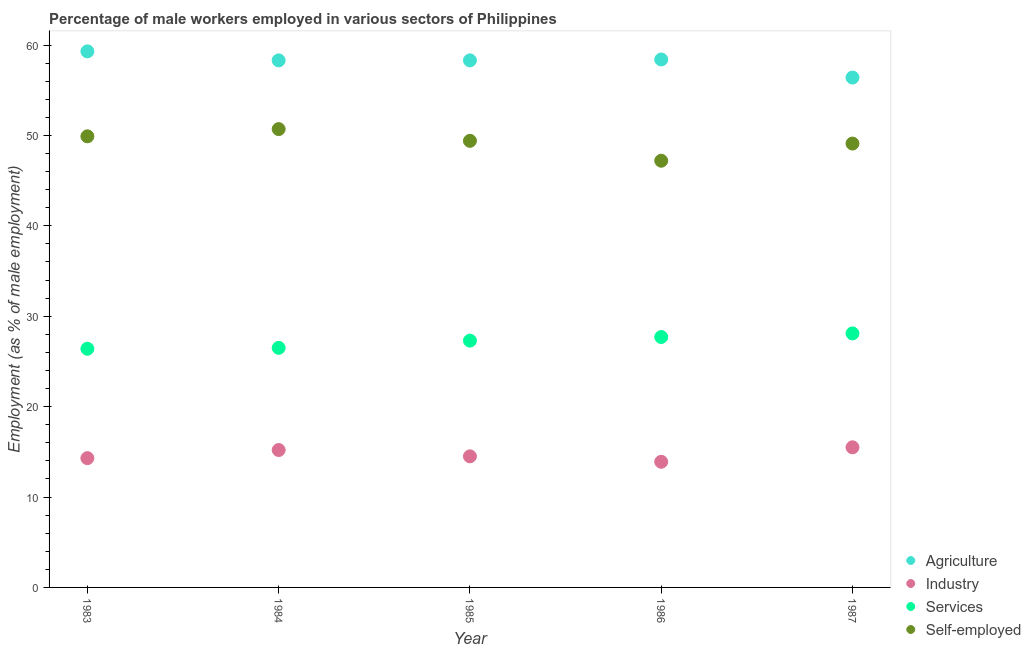Is the number of dotlines equal to the number of legend labels?
Make the answer very short. Yes. What is the percentage of male workers in services in 1986?
Provide a succinct answer. 27.7. Across all years, what is the maximum percentage of male workers in services?
Your answer should be compact. 28.1. Across all years, what is the minimum percentage of male workers in agriculture?
Make the answer very short. 56.4. In which year was the percentage of male workers in industry maximum?
Offer a very short reply. 1987. What is the total percentage of self employed male workers in the graph?
Make the answer very short. 246.3. What is the difference between the percentage of male workers in agriculture in 1985 and that in 1987?
Ensure brevity in your answer.  1.9. What is the difference between the percentage of male workers in services in 1987 and the percentage of male workers in agriculture in 1983?
Ensure brevity in your answer.  -31.2. What is the average percentage of male workers in services per year?
Provide a succinct answer. 27.2. In the year 1984, what is the difference between the percentage of male workers in industry and percentage of male workers in agriculture?
Provide a succinct answer. -43.1. What is the ratio of the percentage of self employed male workers in 1984 to that in 1985?
Your answer should be compact. 1.03. What is the difference between the highest and the second highest percentage of male workers in industry?
Your answer should be compact. 0.3. In how many years, is the percentage of male workers in agriculture greater than the average percentage of male workers in agriculture taken over all years?
Offer a very short reply. 4. Is the sum of the percentage of male workers in agriculture in 1985 and 1987 greater than the maximum percentage of male workers in services across all years?
Make the answer very short. Yes. Is it the case that in every year, the sum of the percentage of self employed male workers and percentage of male workers in agriculture is greater than the sum of percentage of male workers in services and percentage of male workers in industry?
Provide a succinct answer. Yes. Is the percentage of self employed male workers strictly greater than the percentage of male workers in agriculture over the years?
Offer a very short reply. No. Is the percentage of male workers in services strictly less than the percentage of male workers in agriculture over the years?
Your response must be concise. Yes. How many dotlines are there?
Provide a succinct answer. 4. How many years are there in the graph?
Make the answer very short. 5. Does the graph contain any zero values?
Offer a very short reply. No. Does the graph contain grids?
Your response must be concise. No. How are the legend labels stacked?
Keep it short and to the point. Vertical. What is the title of the graph?
Your response must be concise. Percentage of male workers employed in various sectors of Philippines. Does "Payroll services" appear as one of the legend labels in the graph?
Ensure brevity in your answer.  No. What is the label or title of the Y-axis?
Offer a terse response. Employment (as % of male employment). What is the Employment (as % of male employment) of Agriculture in 1983?
Provide a short and direct response. 59.3. What is the Employment (as % of male employment) in Industry in 1983?
Your response must be concise. 14.3. What is the Employment (as % of male employment) of Services in 1983?
Your answer should be compact. 26.4. What is the Employment (as % of male employment) in Self-employed in 1983?
Give a very brief answer. 49.9. What is the Employment (as % of male employment) of Agriculture in 1984?
Give a very brief answer. 58.3. What is the Employment (as % of male employment) of Industry in 1984?
Your answer should be compact. 15.2. What is the Employment (as % of male employment) of Self-employed in 1984?
Give a very brief answer. 50.7. What is the Employment (as % of male employment) in Agriculture in 1985?
Provide a succinct answer. 58.3. What is the Employment (as % of male employment) in Services in 1985?
Your response must be concise. 27.3. What is the Employment (as % of male employment) of Self-employed in 1985?
Provide a short and direct response. 49.4. What is the Employment (as % of male employment) in Agriculture in 1986?
Provide a succinct answer. 58.4. What is the Employment (as % of male employment) of Industry in 1986?
Make the answer very short. 13.9. What is the Employment (as % of male employment) in Services in 1986?
Make the answer very short. 27.7. What is the Employment (as % of male employment) of Self-employed in 1986?
Keep it short and to the point. 47.2. What is the Employment (as % of male employment) in Agriculture in 1987?
Provide a short and direct response. 56.4. What is the Employment (as % of male employment) of Industry in 1987?
Keep it short and to the point. 15.5. What is the Employment (as % of male employment) of Services in 1987?
Offer a terse response. 28.1. What is the Employment (as % of male employment) of Self-employed in 1987?
Ensure brevity in your answer.  49.1. Across all years, what is the maximum Employment (as % of male employment) of Agriculture?
Offer a very short reply. 59.3. Across all years, what is the maximum Employment (as % of male employment) of Services?
Your response must be concise. 28.1. Across all years, what is the maximum Employment (as % of male employment) in Self-employed?
Ensure brevity in your answer.  50.7. Across all years, what is the minimum Employment (as % of male employment) in Agriculture?
Make the answer very short. 56.4. Across all years, what is the minimum Employment (as % of male employment) in Industry?
Keep it short and to the point. 13.9. Across all years, what is the minimum Employment (as % of male employment) of Services?
Offer a terse response. 26.4. Across all years, what is the minimum Employment (as % of male employment) of Self-employed?
Your answer should be compact. 47.2. What is the total Employment (as % of male employment) of Agriculture in the graph?
Ensure brevity in your answer.  290.7. What is the total Employment (as % of male employment) in Industry in the graph?
Offer a very short reply. 73.4. What is the total Employment (as % of male employment) of Services in the graph?
Keep it short and to the point. 136. What is the total Employment (as % of male employment) of Self-employed in the graph?
Ensure brevity in your answer.  246.3. What is the difference between the Employment (as % of male employment) of Services in 1983 and that in 1984?
Offer a terse response. -0.1. What is the difference between the Employment (as % of male employment) of Self-employed in 1983 and that in 1985?
Your answer should be very brief. 0.5. What is the difference between the Employment (as % of male employment) in Agriculture in 1983 and that in 1986?
Keep it short and to the point. 0.9. What is the difference between the Employment (as % of male employment) of Industry in 1983 and that in 1986?
Ensure brevity in your answer.  0.4. What is the difference between the Employment (as % of male employment) of Services in 1983 and that in 1986?
Ensure brevity in your answer.  -1.3. What is the difference between the Employment (as % of male employment) of Industry in 1983 and that in 1987?
Offer a very short reply. -1.2. What is the difference between the Employment (as % of male employment) of Services in 1983 and that in 1987?
Keep it short and to the point. -1.7. What is the difference between the Employment (as % of male employment) of Industry in 1984 and that in 1985?
Your answer should be very brief. 0.7. What is the difference between the Employment (as % of male employment) in Services in 1984 and that in 1985?
Give a very brief answer. -0.8. What is the difference between the Employment (as % of male employment) of Industry in 1984 and that in 1986?
Your response must be concise. 1.3. What is the difference between the Employment (as % of male employment) in Services in 1984 and that in 1986?
Offer a very short reply. -1.2. What is the difference between the Employment (as % of male employment) of Self-employed in 1984 and that in 1986?
Ensure brevity in your answer.  3.5. What is the difference between the Employment (as % of male employment) in Agriculture in 1984 and that in 1987?
Your response must be concise. 1.9. What is the difference between the Employment (as % of male employment) of Industry in 1984 and that in 1987?
Offer a very short reply. -0.3. What is the difference between the Employment (as % of male employment) in Services in 1984 and that in 1987?
Make the answer very short. -1.6. What is the difference between the Employment (as % of male employment) in Self-employed in 1985 and that in 1986?
Provide a succinct answer. 2.2. What is the difference between the Employment (as % of male employment) in Services in 1985 and that in 1987?
Make the answer very short. -0.8. What is the difference between the Employment (as % of male employment) of Self-employed in 1985 and that in 1987?
Your answer should be compact. 0.3. What is the difference between the Employment (as % of male employment) of Agriculture in 1986 and that in 1987?
Ensure brevity in your answer.  2. What is the difference between the Employment (as % of male employment) of Industry in 1986 and that in 1987?
Your response must be concise. -1.6. What is the difference between the Employment (as % of male employment) in Services in 1986 and that in 1987?
Offer a terse response. -0.4. What is the difference between the Employment (as % of male employment) in Agriculture in 1983 and the Employment (as % of male employment) in Industry in 1984?
Your answer should be compact. 44.1. What is the difference between the Employment (as % of male employment) in Agriculture in 1983 and the Employment (as % of male employment) in Services in 1984?
Give a very brief answer. 32.8. What is the difference between the Employment (as % of male employment) of Industry in 1983 and the Employment (as % of male employment) of Services in 1984?
Your answer should be very brief. -12.2. What is the difference between the Employment (as % of male employment) in Industry in 1983 and the Employment (as % of male employment) in Self-employed in 1984?
Give a very brief answer. -36.4. What is the difference between the Employment (as % of male employment) in Services in 1983 and the Employment (as % of male employment) in Self-employed in 1984?
Make the answer very short. -24.3. What is the difference between the Employment (as % of male employment) of Agriculture in 1983 and the Employment (as % of male employment) of Industry in 1985?
Keep it short and to the point. 44.8. What is the difference between the Employment (as % of male employment) in Agriculture in 1983 and the Employment (as % of male employment) in Services in 1985?
Make the answer very short. 32. What is the difference between the Employment (as % of male employment) of Agriculture in 1983 and the Employment (as % of male employment) of Self-employed in 1985?
Ensure brevity in your answer.  9.9. What is the difference between the Employment (as % of male employment) of Industry in 1983 and the Employment (as % of male employment) of Services in 1985?
Your answer should be compact. -13. What is the difference between the Employment (as % of male employment) of Industry in 1983 and the Employment (as % of male employment) of Self-employed in 1985?
Offer a very short reply. -35.1. What is the difference between the Employment (as % of male employment) in Services in 1983 and the Employment (as % of male employment) in Self-employed in 1985?
Offer a very short reply. -23. What is the difference between the Employment (as % of male employment) of Agriculture in 1983 and the Employment (as % of male employment) of Industry in 1986?
Ensure brevity in your answer.  45.4. What is the difference between the Employment (as % of male employment) in Agriculture in 1983 and the Employment (as % of male employment) in Services in 1986?
Ensure brevity in your answer.  31.6. What is the difference between the Employment (as % of male employment) of Industry in 1983 and the Employment (as % of male employment) of Services in 1986?
Offer a very short reply. -13.4. What is the difference between the Employment (as % of male employment) in Industry in 1983 and the Employment (as % of male employment) in Self-employed in 1986?
Offer a very short reply. -32.9. What is the difference between the Employment (as % of male employment) in Services in 1983 and the Employment (as % of male employment) in Self-employed in 1986?
Keep it short and to the point. -20.8. What is the difference between the Employment (as % of male employment) in Agriculture in 1983 and the Employment (as % of male employment) in Industry in 1987?
Make the answer very short. 43.8. What is the difference between the Employment (as % of male employment) in Agriculture in 1983 and the Employment (as % of male employment) in Services in 1987?
Provide a succinct answer. 31.2. What is the difference between the Employment (as % of male employment) of Agriculture in 1983 and the Employment (as % of male employment) of Self-employed in 1987?
Keep it short and to the point. 10.2. What is the difference between the Employment (as % of male employment) of Industry in 1983 and the Employment (as % of male employment) of Self-employed in 1987?
Your answer should be very brief. -34.8. What is the difference between the Employment (as % of male employment) in Services in 1983 and the Employment (as % of male employment) in Self-employed in 1987?
Your response must be concise. -22.7. What is the difference between the Employment (as % of male employment) of Agriculture in 1984 and the Employment (as % of male employment) of Industry in 1985?
Offer a terse response. 43.8. What is the difference between the Employment (as % of male employment) in Agriculture in 1984 and the Employment (as % of male employment) in Services in 1985?
Offer a very short reply. 31. What is the difference between the Employment (as % of male employment) in Industry in 1984 and the Employment (as % of male employment) in Self-employed in 1985?
Your response must be concise. -34.2. What is the difference between the Employment (as % of male employment) in Services in 1984 and the Employment (as % of male employment) in Self-employed in 1985?
Offer a terse response. -22.9. What is the difference between the Employment (as % of male employment) of Agriculture in 1984 and the Employment (as % of male employment) of Industry in 1986?
Offer a very short reply. 44.4. What is the difference between the Employment (as % of male employment) in Agriculture in 1984 and the Employment (as % of male employment) in Services in 1986?
Give a very brief answer. 30.6. What is the difference between the Employment (as % of male employment) in Agriculture in 1984 and the Employment (as % of male employment) in Self-employed in 1986?
Offer a terse response. 11.1. What is the difference between the Employment (as % of male employment) of Industry in 1984 and the Employment (as % of male employment) of Services in 1986?
Give a very brief answer. -12.5. What is the difference between the Employment (as % of male employment) of Industry in 1984 and the Employment (as % of male employment) of Self-employed in 1986?
Provide a short and direct response. -32. What is the difference between the Employment (as % of male employment) in Services in 1984 and the Employment (as % of male employment) in Self-employed in 1986?
Ensure brevity in your answer.  -20.7. What is the difference between the Employment (as % of male employment) in Agriculture in 1984 and the Employment (as % of male employment) in Industry in 1987?
Your response must be concise. 42.8. What is the difference between the Employment (as % of male employment) of Agriculture in 1984 and the Employment (as % of male employment) of Services in 1987?
Give a very brief answer. 30.2. What is the difference between the Employment (as % of male employment) in Agriculture in 1984 and the Employment (as % of male employment) in Self-employed in 1987?
Your answer should be compact. 9.2. What is the difference between the Employment (as % of male employment) of Industry in 1984 and the Employment (as % of male employment) of Services in 1987?
Provide a short and direct response. -12.9. What is the difference between the Employment (as % of male employment) of Industry in 1984 and the Employment (as % of male employment) of Self-employed in 1987?
Ensure brevity in your answer.  -33.9. What is the difference between the Employment (as % of male employment) of Services in 1984 and the Employment (as % of male employment) of Self-employed in 1987?
Offer a very short reply. -22.6. What is the difference between the Employment (as % of male employment) of Agriculture in 1985 and the Employment (as % of male employment) of Industry in 1986?
Your answer should be compact. 44.4. What is the difference between the Employment (as % of male employment) of Agriculture in 1985 and the Employment (as % of male employment) of Services in 1986?
Provide a short and direct response. 30.6. What is the difference between the Employment (as % of male employment) in Industry in 1985 and the Employment (as % of male employment) in Services in 1986?
Your answer should be very brief. -13.2. What is the difference between the Employment (as % of male employment) in Industry in 1985 and the Employment (as % of male employment) in Self-employed in 1986?
Offer a terse response. -32.7. What is the difference between the Employment (as % of male employment) of Services in 1985 and the Employment (as % of male employment) of Self-employed in 1986?
Your answer should be compact. -19.9. What is the difference between the Employment (as % of male employment) of Agriculture in 1985 and the Employment (as % of male employment) of Industry in 1987?
Give a very brief answer. 42.8. What is the difference between the Employment (as % of male employment) of Agriculture in 1985 and the Employment (as % of male employment) of Services in 1987?
Offer a very short reply. 30.2. What is the difference between the Employment (as % of male employment) in Industry in 1985 and the Employment (as % of male employment) in Services in 1987?
Make the answer very short. -13.6. What is the difference between the Employment (as % of male employment) in Industry in 1985 and the Employment (as % of male employment) in Self-employed in 1987?
Your response must be concise. -34.6. What is the difference between the Employment (as % of male employment) in Services in 1985 and the Employment (as % of male employment) in Self-employed in 1987?
Offer a very short reply. -21.8. What is the difference between the Employment (as % of male employment) of Agriculture in 1986 and the Employment (as % of male employment) of Industry in 1987?
Offer a terse response. 42.9. What is the difference between the Employment (as % of male employment) of Agriculture in 1986 and the Employment (as % of male employment) of Services in 1987?
Give a very brief answer. 30.3. What is the difference between the Employment (as % of male employment) of Industry in 1986 and the Employment (as % of male employment) of Self-employed in 1987?
Give a very brief answer. -35.2. What is the difference between the Employment (as % of male employment) of Services in 1986 and the Employment (as % of male employment) of Self-employed in 1987?
Your answer should be very brief. -21.4. What is the average Employment (as % of male employment) of Agriculture per year?
Your answer should be compact. 58.14. What is the average Employment (as % of male employment) of Industry per year?
Ensure brevity in your answer.  14.68. What is the average Employment (as % of male employment) in Services per year?
Provide a short and direct response. 27.2. What is the average Employment (as % of male employment) in Self-employed per year?
Make the answer very short. 49.26. In the year 1983, what is the difference between the Employment (as % of male employment) of Agriculture and Employment (as % of male employment) of Industry?
Offer a very short reply. 45. In the year 1983, what is the difference between the Employment (as % of male employment) of Agriculture and Employment (as % of male employment) of Services?
Give a very brief answer. 32.9. In the year 1983, what is the difference between the Employment (as % of male employment) of Industry and Employment (as % of male employment) of Services?
Your answer should be very brief. -12.1. In the year 1983, what is the difference between the Employment (as % of male employment) in Industry and Employment (as % of male employment) in Self-employed?
Your answer should be compact. -35.6. In the year 1983, what is the difference between the Employment (as % of male employment) of Services and Employment (as % of male employment) of Self-employed?
Your response must be concise. -23.5. In the year 1984, what is the difference between the Employment (as % of male employment) in Agriculture and Employment (as % of male employment) in Industry?
Provide a succinct answer. 43.1. In the year 1984, what is the difference between the Employment (as % of male employment) in Agriculture and Employment (as % of male employment) in Services?
Offer a very short reply. 31.8. In the year 1984, what is the difference between the Employment (as % of male employment) in Industry and Employment (as % of male employment) in Services?
Give a very brief answer. -11.3. In the year 1984, what is the difference between the Employment (as % of male employment) of Industry and Employment (as % of male employment) of Self-employed?
Provide a succinct answer. -35.5. In the year 1984, what is the difference between the Employment (as % of male employment) in Services and Employment (as % of male employment) in Self-employed?
Provide a succinct answer. -24.2. In the year 1985, what is the difference between the Employment (as % of male employment) of Agriculture and Employment (as % of male employment) of Industry?
Provide a succinct answer. 43.8. In the year 1985, what is the difference between the Employment (as % of male employment) of Agriculture and Employment (as % of male employment) of Services?
Provide a short and direct response. 31. In the year 1985, what is the difference between the Employment (as % of male employment) in Industry and Employment (as % of male employment) in Services?
Your answer should be very brief. -12.8. In the year 1985, what is the difference between the Employment (as % of male employment) in Industry and Employment (as % of male employment) in Self-employed?
Keep it short and to the point. -34.9. In the year 1985, what is the difference between the Employment (as % of male employment) of Services and Employment (as % of male employment) of Self-employed?
Your response must be concise. -22.1. In the year 1986, what is the difference between the Employment (as % of male employment) in Agriculture and Employment (as % of male employment) in Industry?
Your answer should be compact. 44.5. In the year 1986, what is the difference between the Employment (as % of male employment) in Agriculture and Employment (as % of male employment) in Services?
Ensure brevity in your answer.  30.7. In the year 1986, what is the difference between the Employment (as % of male employment) of Agriculture and Employment (as % of male employment) of Self-employed?
Provide a short and direct response. 11.2. In the year 1986, what is the difference between the Employment (as % of male employment) of Industry and Employment (as % of male employment) of Self-employed?
Keep it short and to the point. -33.3. In the year 1986, what is the difference between the Employment (as % of male employment) in Services and Employment (as % of male employment) in Self-employed?
Provide a short and direct response. -19.5. In the year 1987, what is the difference between the Employment (as % of male employment) of Agriculture and Employment (as % of male employment) of Industry?
Ensure brevity in your answer.  40.9. In the year 1987, what is the difference between the Employment (as % of male employment) in Agriculture and Employment (as % of male employment) in Services?
Ensure brevity in your answer.  28.3. In the year 1987, what is the difference between the Employment (as % of male employment) in Agriculture and Employment (as % of male employment) in Self-employed?
Your response must be concise. 7.3. In the year 1987, what is the difference between the Employment (as % of male employment) of Industry and Employment (as % of male employment) of Self-employed?
Give a very brief answer. -33.6. In the year 1987, what is the difference between the Employment (as % of male employment) in Services and Employment (as % of male employment) in Self-employed?
Your response must be concise. -21. What is the ratio of the Employment (as % of male employment) in Agriculture in 1983 to that in 1984?
Give a very brief answer. 1.02. What is the ratio of the Employment (as % of male employment) in Industry in 1983 to that in 1984?
Your response must be concise. 0.94. What is the ratio of the Employment (as % of male employment) of Services in 1983 to that in 1984?
Provide a short and direct response. 1. What is the ratio of the Employment (as % of male employment) of Self-employed in 1983 to that in 1984?
Provide a short and direct response. 0.98. What is the ratio of the Employment (as % of male employment) of Agriculture in 1983 to that in 1985?
Your answer should be compact. 1.02. What is the ratio of the Employment (as % of male employment) in Industry in 1983 to that in 1985?
Keep it short and to the point. 0.99. What is the ratio of the Employment (as % of male employment) of Services in 1983 to that in 1985?
Your answer should be compact. 0.97. What is the ratio of the Employment (as % of male employment) in Self-employed in 1983 to that in 1985?
Your answer should be very brief. 1.01. What is the ratio of the Employment (as % of male employment) of Agriculture in 1983 to that in 1986?
Make the answer very short. 1.02. What is the ratio of the Employment (as % of male employment) of Industry in 1983 to that in 1986?
Offer a terse response. 1.03. What is the ratio of the Employment (as % of male employment) of Services in 1983 to that in 1986?
Ensure brevity in your answer.  0.95. What is the ratio of the Employment (as % of male employment) in Self-employed in 1983 to that in 1986?
Make the answer very short. 1.06. What is the ratio of the Employment (as % of male employment) in Agriculture in 1983 to that in 1987?
Provide a short and direct response. 1.05. What is the ratio of the Employment (as % of male employment) in Industry in 1983 to that in 1987?
Your answer should be very brief. 0.92. What is the ratio of the Employment (as % of male employment) in Services in 1983 to that in 1987?
Provide a succinct answer. 0.94. What is the ratio of the Employment (as % of male employment) of Self-employed in 1983 to that in 1987?
Your answer should be compact. 1.02. What is the ratio of the Employment (as % of male employment) of Industry in 1984 to that in 1985?
Ensure brevity in your answer.  1.05. What is the ratio of the Employment (as % of male employment) of Services in 1984 to that in 1985?
Your response must be concise. 0.97. What is the ratio of the Employment (as % of male employment) of Self-employed in 1984 to that in 1985?
Your answer should be very brief. 1.03. What is the ratio of the Employment (as % of male employment) in Industry in 1984 to that in 1986?
Make the answer very short. 1.09. What is the ratio of the Employment (as % of male employment) in Services in 1984 to that in 1986?
Offer a terse response. 0.96. What is the ratio of the Employment (as % of male employment) in Self-employed in 1984 to that in 1986?
Offer a terse response. 1.07. What is the ratio of the Employment (as % of male employment) in Agriculture in 1984 to that in 1987?
Your answer should be very brief. 1.03. What is the ratio of the Employment (as % of male employment) of Industry in 1984 to that in 1987?
Give a very brief answer. 0.98. What is the ratio of the Employment (as % of male employment) in Services in 1984 to that in 1987?
Your response must be concise. 0.94. What is the ratio of the Employment (as % of male employment) of Self-employed in 1984 to that in 1987?
Ensure brevity in your answer.  1.03. What is the ratio of the Employment (as % of male employment) of Agriculture in 1985 to that in 1986?
Offer a very short reply. 1. What is the ratio of the Employment (as % of male employment) of Industry in 1985 to that in 1986?
Provide a succinct answer. 1.04. What is the ratio of the Employment (as % of male employment) in Services in 1985 to that in 1986?
Offer a very short reply. 0.99. What is the ratio of the Employment (as % of male employment) in Self-employed in 1985 to that in 1986?
Your response must be concise. 1.05. What is the ratio of the Employment (as % of male employment) in Agriculture in 1985 to that in 1987?
Offer a terse response. 1.03. What is the ratio of the Employment (as % of male employment) of Industry in 1985 to that in 1987?
Give a very brief answer. 0.94. What is the ratio of the Employment (as % of male employment) in Services in 1985 to that in 1987?
Your answer should be very brief. 0.97. What is the ratio of the Employment (as % of male employment) in Self-employed in 1985 to that in 1987?
Provide a short and direct response. 1.01. What is the ratio of the Employment (as % of male employment) in Agriculture in 1986 to that in 1987?
Your answer should be very brief. 1.04. What is the ratio of the Employment (as % of male employment) of Industry in 1986 to that in 1987?
Your answer should be compact. 0.9. What is the ratio of the Employment (as % of male employment) in Services in 1986 to that in 1987?
Your response must be concise. 0.99. What is the ratio of the Employment (as % of male employment) of Self-employed in 1986 to that in 1987?
Give a very brief answer. 0.96. What is the difference between the highest and the second highest Employment (as % of male employment) of Industry?
Keep it short and to the point. 0.3. What is the difference between the highest and the second highest Employment (as % of male employment) of Services?
Make the answer very short. 0.4. What is the difference between the highest and the lowest Employment (as % of male employment) in Agriculture?
Provide a succinct answer. 2.9. What is the difference between the highest and the lowest Employment (as % of male employment) of Services?
Offer a very short reply. 1.7. What is the difference between the highest and the lowest Employment (as % of male employment) of Self-employed?
Provide a short and direct response. 3.5. 